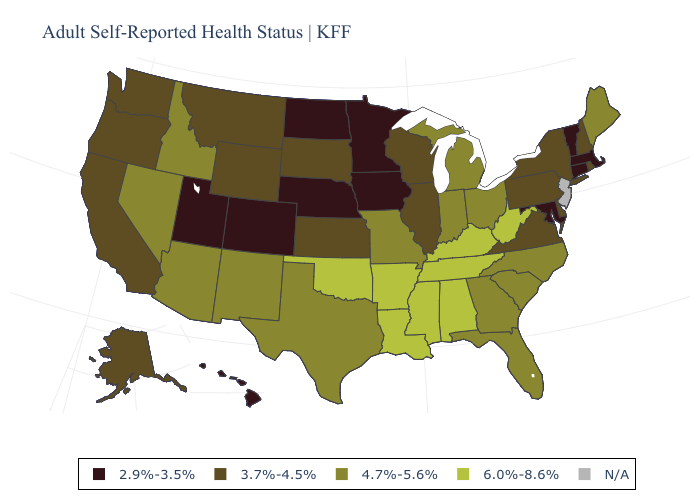Name the states that have a value in the range 2.9%-3.5%?
Concise answer only. Colorado, Connecticut, Hawaii, Iowa, Maryland, Massachusetts, Minnesota, Nebraska, North Dakota, Utah, Vermont. What is the value of Iowa?
Be succinct. 2.9%-3.5%. Does Minnesota have the lowest value in the USA?
Be succinct. Yes. Name the states that have a value in the range N/A?
Concise answer only. New Jersey. What is the value of Rhode Island?
Keep it brief. 3.7%-4.5%. Name the states that have a value in the range N/A?
Concise answer only. New Jersey. What is the highest value in states that border West Virginia?
Write a very short answer. 6.0%-8.6%. Which states have the highest value in the USA?
Write a very short answer. Alabama, Arkansas, Kentucky, Louisiana, Mississippi, Oklahoma, Tennessee, West Virginia. How many symbols are there in the legend?
Quick response, please. 5. Among the states that border Washington , does Idaho have the lowest value?
Quick response, please. No. Name the states that have a value in the range 4.7%-5.6%?
Quick response, please. Arizona, Florida, Georgia, Idaho, Indiana, Maine, Michigan, Missouri, Nevada, New Mexico, North Carolina, Ohio, South Carolina, Texas. Which states have the lowest value in the West?
Write a very short answer. Colorado, Hawaii, Utah. Does the map have missing data?
Quick response, please. Yes. What is the value of Massachusetts?
Be succinct. 2.9%-3.5%. 